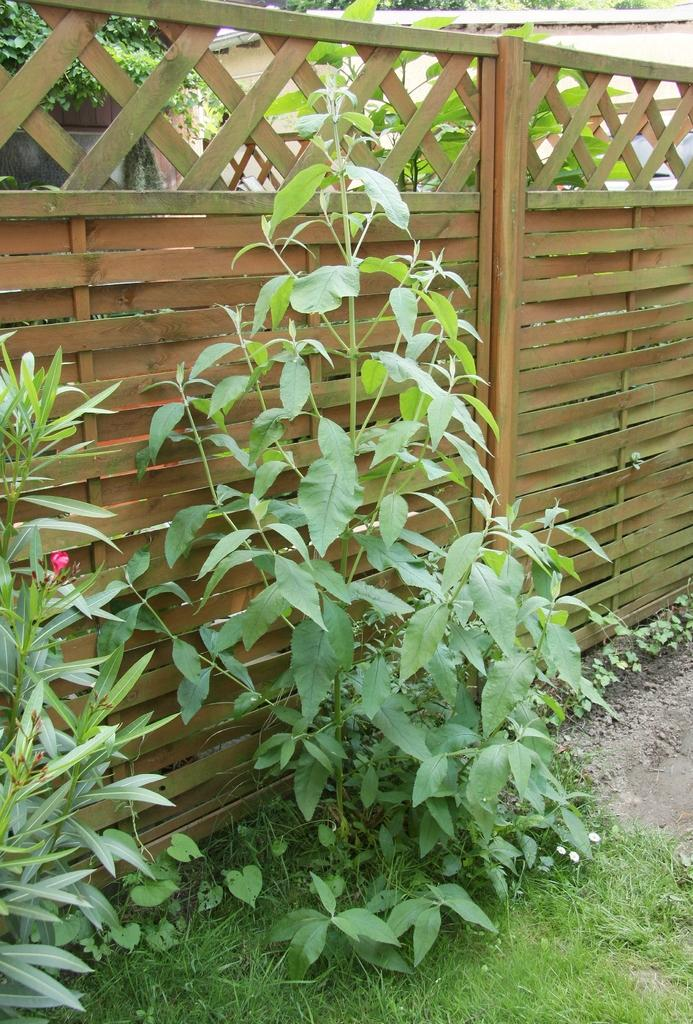What type of vegetation is present in the image? There is grass and plants in the image. What kind of barrier can be seen in the image? There is a wooden fence in the image. What can be seen in the background of the image? There are trees in the background of the image. Can you see any dinosaurs in the image? No, there are no dinosaurs present in the image. What is the hope that the grass and plants are providing in the image? The image does not convey any sense of hope; it simply depicts grass, plants, a wooden fence, and trees. 